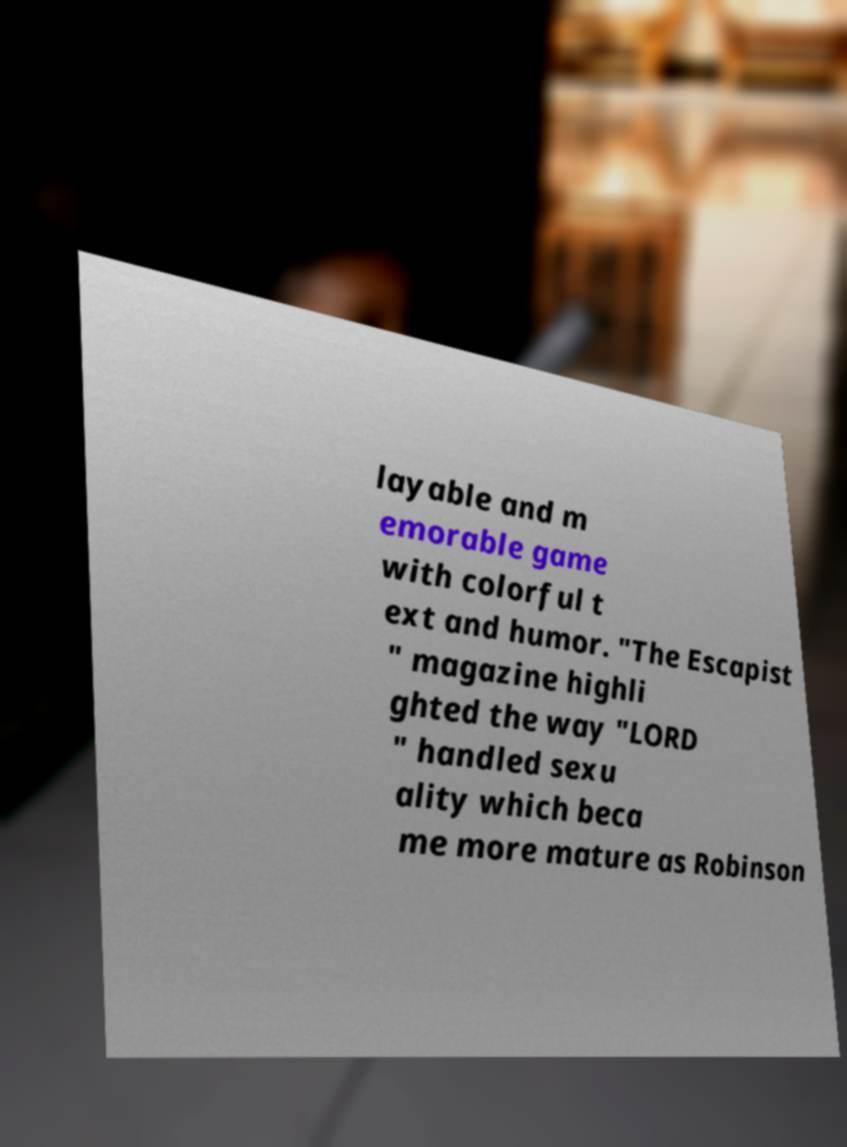Please identify and transcribe the text found in this image. layable and m emorable game with colorful t ext and humor. "The Escapist " magazine highli ghted the way "LORD " handled sexu ality which beca me more mature as Robinson 